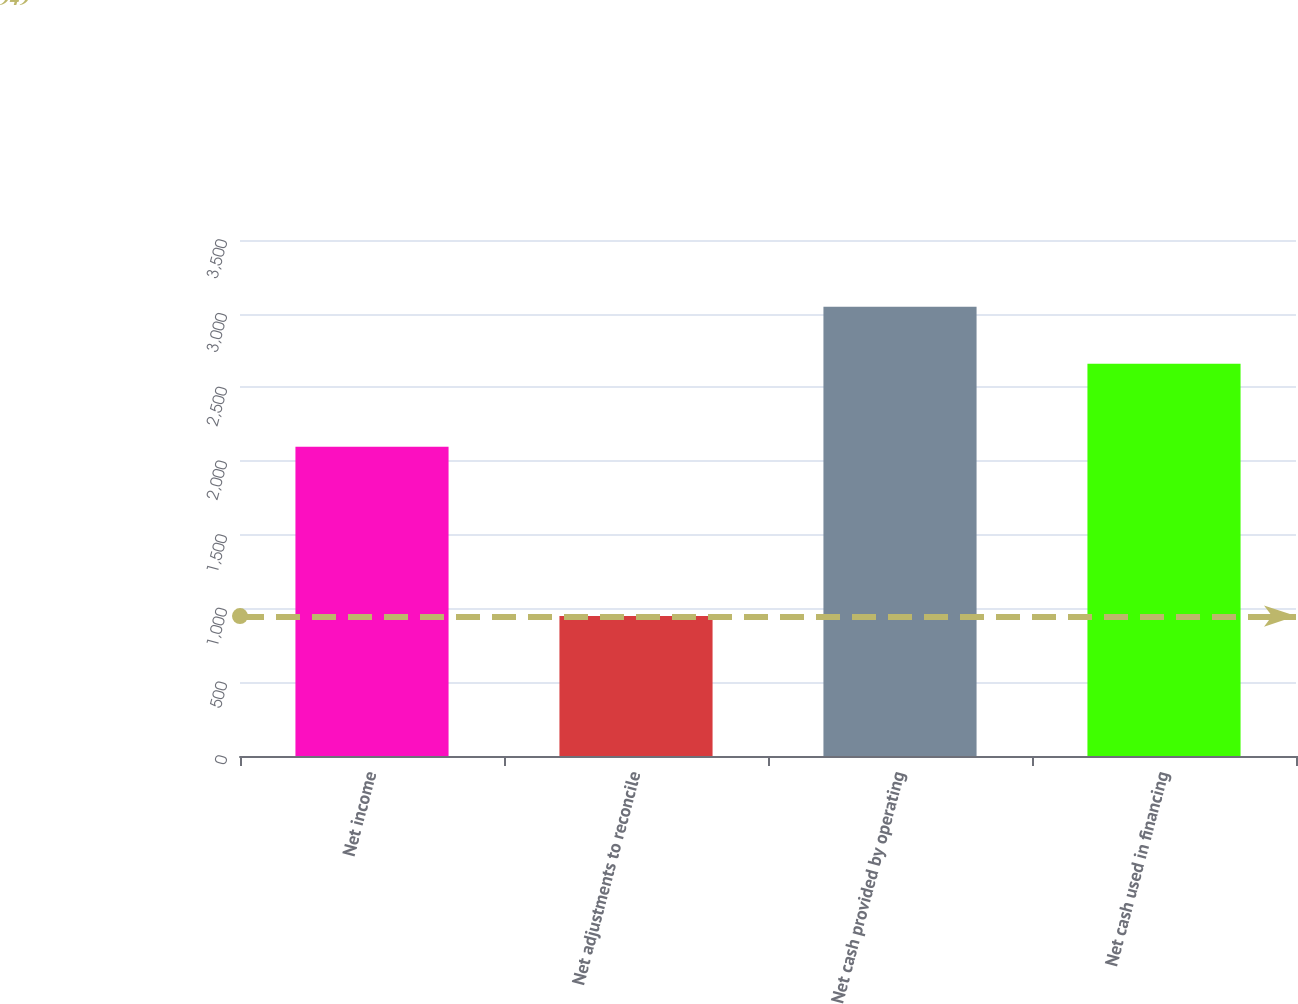Convert chart. <chart><loc_0><loc_0><loc_500><loc_500><bar_chart><fcel>Net income<fcel>Net adjustments to reconcile<fcel>Net cash provided by operating<fcel>Net cash used in financing<nl><fcel>2098<fcel>949<fcel>3047<fcel>2660<nl></chart> 